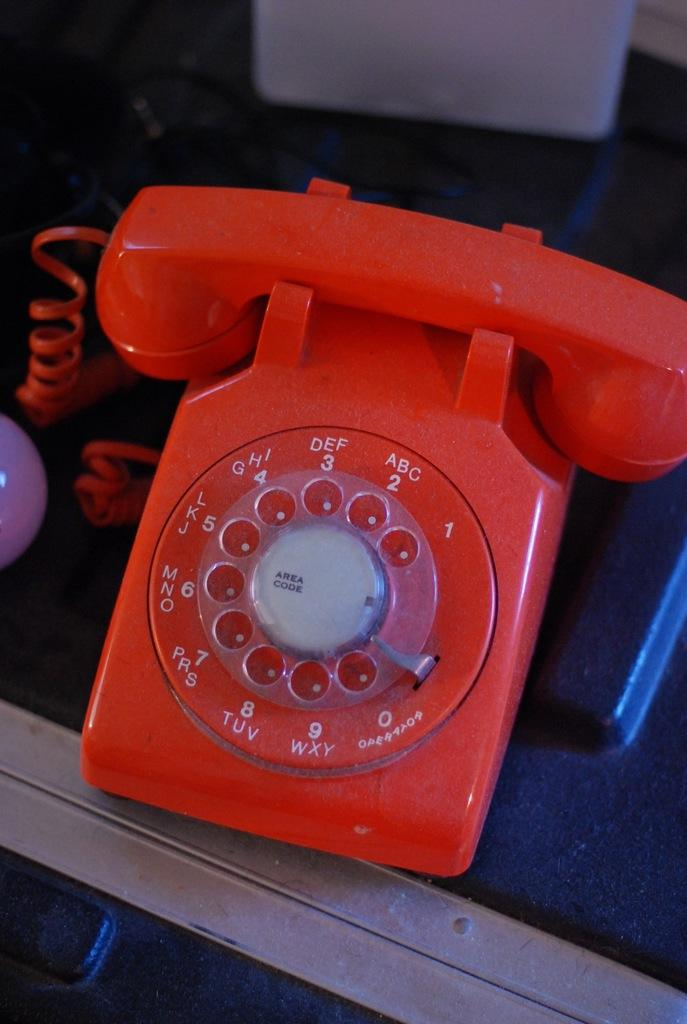<image>
Relay a brief, clear account of the picture shown. An old red telephone that has area code in the middle. 